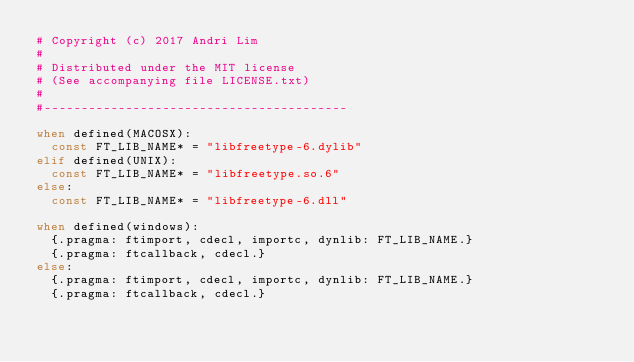Convert code to text. <code><loc_0><loc_0><loc_500><loc_500><_Nim_># Copyright (c) 2017 Andri Lim
#
# Distributed under the MIT license
# (See accompanying file LICENSE.txt)
#
#-----------------------------------------

when defined(MACOSX):
  const FT_LIB_NAME* = "libfreetype-6.dylib"
elif defined(UNIX):
  const FT_LIB_NAME* = "libfreetype.so.6"
else:
  const FT_LIB_NAME* = "libfreetype-6.dll"

when defined(windows):
  {.pragma: ftimport, cdecl, importc, dynlib: FT_LIB_NAME.}
  {.pragma: ftcallback, cdecl.}
else:
  {.pragma: ftimport, cdecl, importc, dynlib: FT_LIB_NAME.}
  {.pragma: ftcallback, cdecl.}</code> 